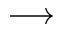Convert formula to latex. <formula><loc_0><loc_0><loc_500><loc_500>\longrightarrow</formula> 